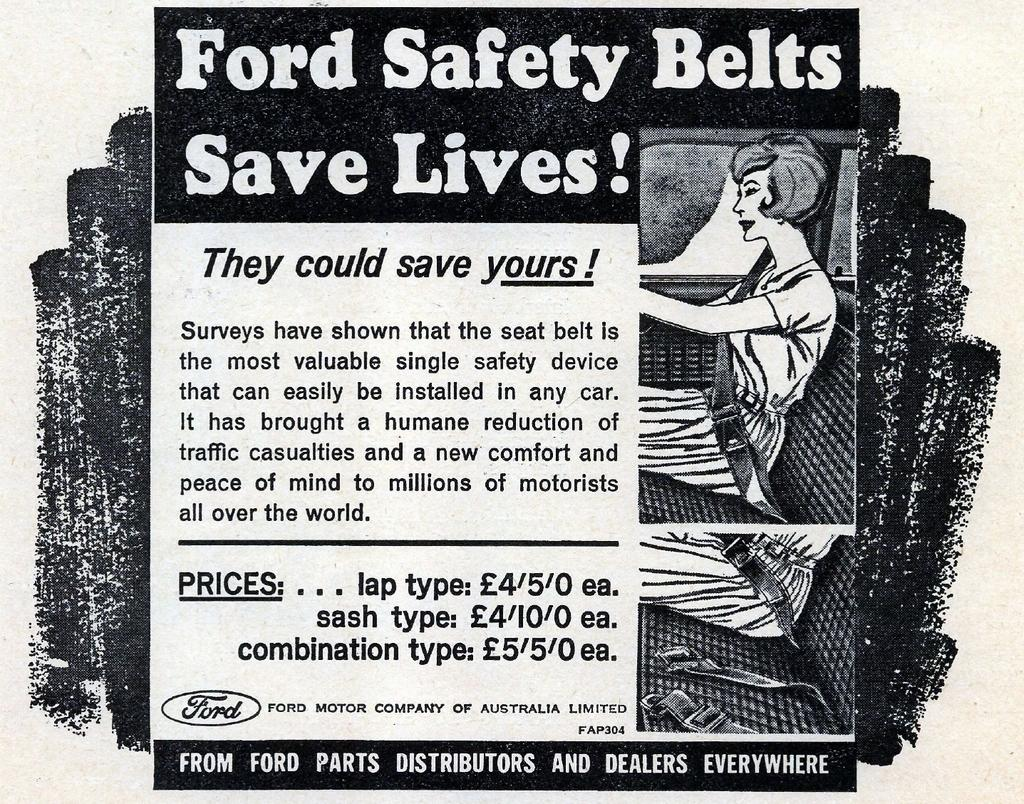What type of visual is the image? The image resembles a poster. Can you describe the lady in the image? There is a lady sitting on the right side of the image. What else can be seen in the background of the image? There is text visible in the background of the image. What type of beam is holding up the lady in the image? There is no beam present in the image, and the lady is sitting, not being held up by any structure. How much sugar is visible in the image? There is no sugar present in the image. 